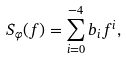Convert formula to latex. <formula><loc_0><loc_0><loc_500><loc_500>S _ { \varphi } ( f ) = \sum ^ { - 4 } _ { i = 0 } b _ { i } f ^ { i } ,</formula> 